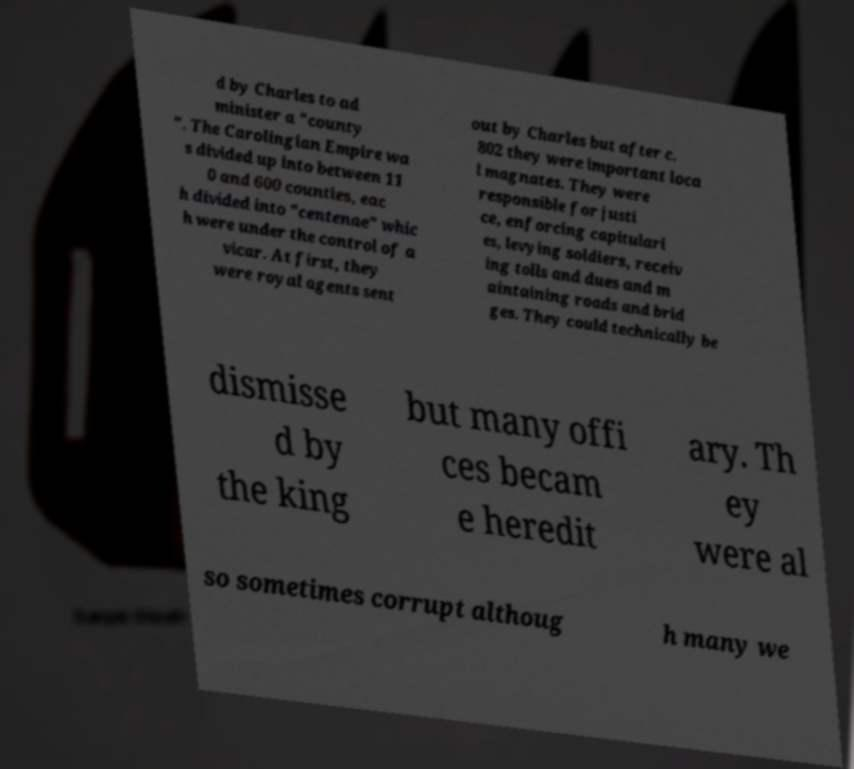Could you assist in decoding the text presented in this image and type it out clearly? d by Charles to ad minister a "county ". The Carolingian Empire wa s divided up into between 11 0 and 600 counties, eac h divided into "centenae" whic h were under the control of a vicar. At first, they were royal agents sent out by Charles but after c. 802 they were important loca l magnates. They were responsible for justi ce, enforcing capitulari es, levying soldiers, receiv ing tolls and dues and m aintaining roads and brid ges. They could technically be dismisse d by the king but many offi ces becam e heredit ary. Th ey were al so sometimes corrupt althoug h many we 